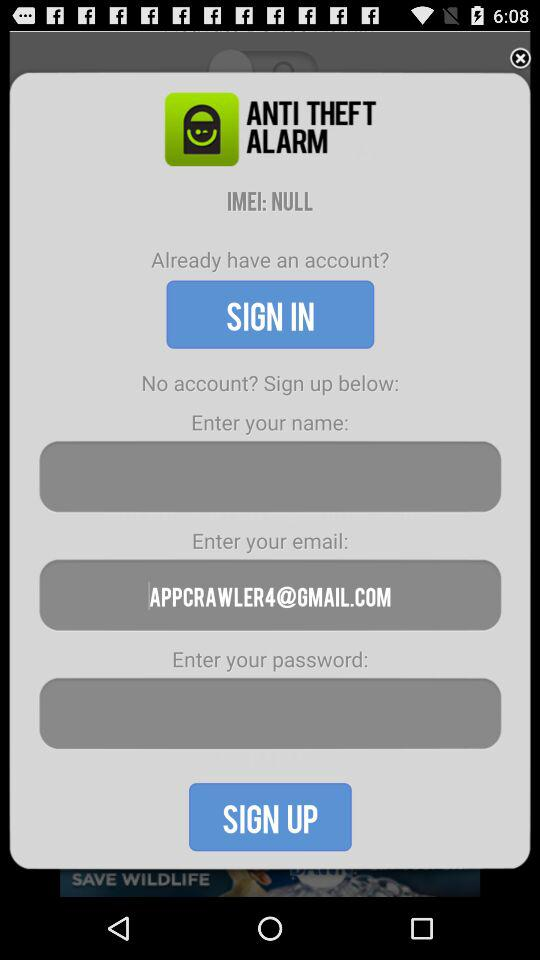How many input fields are there for sign up?
Answer the question using a single word or phrase. 3 